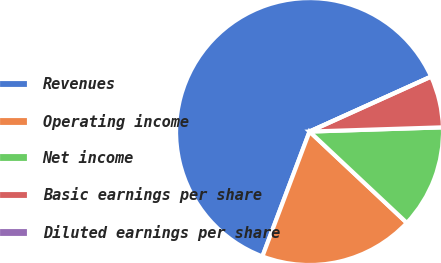Convert chart. <chart><loc_0><loc_0><loc_500><loc_500><pie_chart><fcel>Revenues<fcel>Operating income<fcel>Net income<fcel>Basic earnings per share<fcel>Diluted earnings per share<nl><fcel>62.5%<fcel>18.75%<fcel>12.5%<fcel>6.25%<fcel>0.0%<nl></chart> 